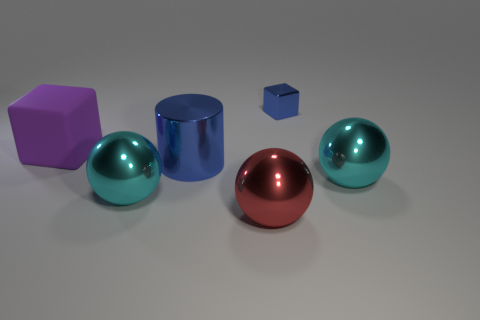Subtract all large cyan balls. How many balls are left? 1 Subtract all cyan balls. How many balls are left? 1 Subtract all blocks. How many objects are left? 4 Add 1 tiny blocks. How many objects exist? 7 Subtract 0 green cylinders. How many objects are left? 6 Subtract 1 cubes. How many cubes are left? 1 Subtract all red cubes. Subtract all purple cylinders. How many cubes are left? 2 Subtract all yellow blocks. How many gray spheres are left? 0 Subtract all small red metallic cylinders. Subtract all small shiny cubes. How many objects are left? 5 Add 2 blue metallic cylinders. How many blue metallic cylinders are left? 3 